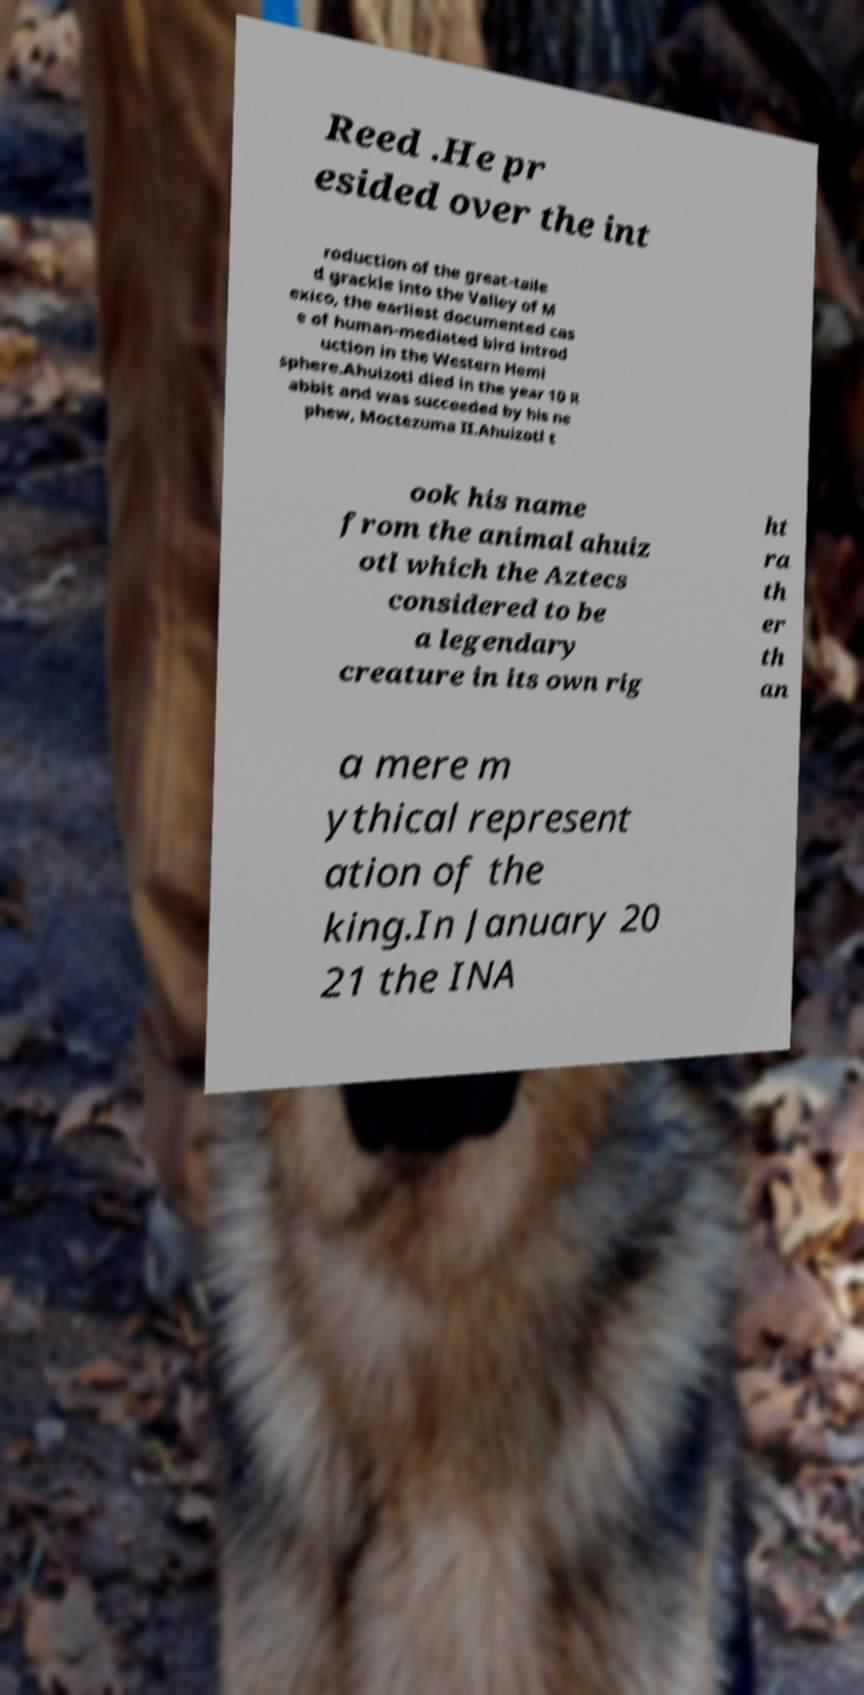Could you extract and type out the text from this image? Reed .He pr esided over the int roduction of the great-taile d grackle into the Valley of M exico, the earliest documented cas e of human-mediated bird introd uction in the Western Hemi sphere.Ahuizotl died in the year 10 R abbit and was succeeded by his ne phew, Moctezuma II.Ahuizotl t ook his name from the animal ahuiz otl which the Aztecs considered to be a legendary creature in its own rig ht ra th er th an a mere m ythical represent ation of the king.In January 20 21 the INA 